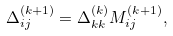Convert formula to latex. <formula><loc_0><loc_0><loc_500><loc_500>\Delta _ { i j } ^ { ( k + 1 ) } = \Delta _ { k k } ^ { ( k ) } M _ { i j } ^ { ( k + 1 ) } ,</formula> 